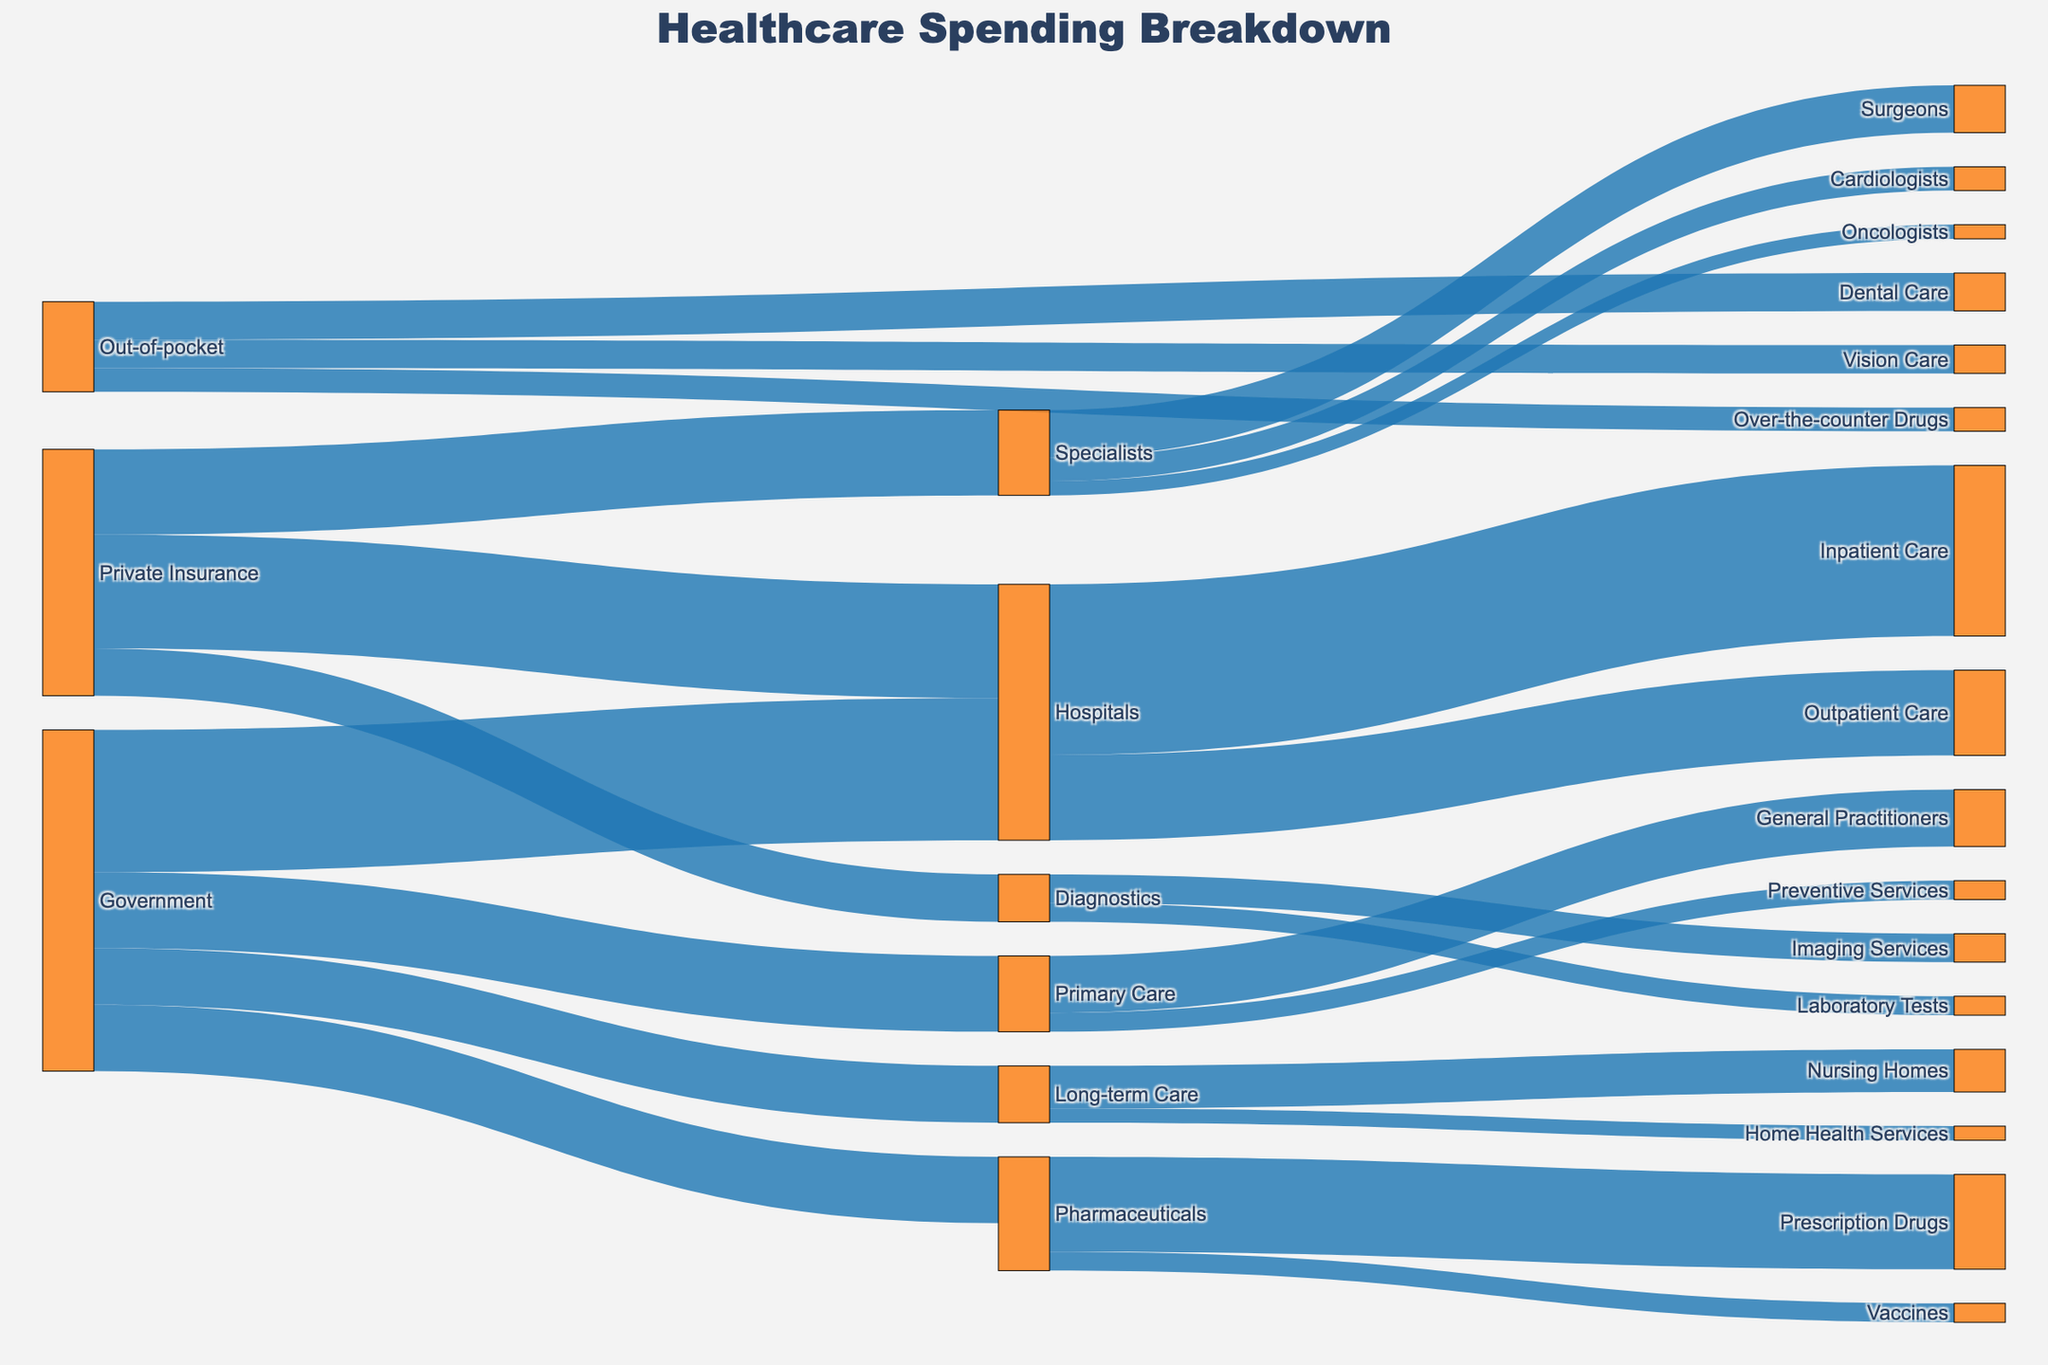What is the total healthcare spending by the Government? Sum the values directed from the Government to each target (Hospitals, Primary Care, Pharmaceuticals, Long-term Care): 150 + 80 + 70 + 60 = 360
Answer: 360 What sector receives the highest funding from Private Insurance? Compare the values directed from Private Insurance to Hospitals, Specialists, and Diagnostics. Hospitals receive 120, Specialists receive 90, and Diagnostics receive 50. The highest is Hospitals with 120
Answer: Hospitals What is the total spending on Hospitals regardless of the funding source? Sum the values directed to Hospitals from Government (150) and Private Insurance (120): 150 + 120 = 270
Answer: 270 How much is spent on General Practitioners from Primary Care? Refer to the target value from Primary Care to General Practitioners, which is 60
Answer: 60 Which funding source contributes the least to healthcare spending? Compare the total contributions by Government (360), Private Insurance (260), and Out-of-pocket (95). The least is Out-of-pocket with 95
Answer: Out-of-pocket What percentage of Government funding goes to Hospitals? Government funding is 360, with 150 going to Hospitals. Calculate the percentage: (150/360) * 100 ≈ 41.67%
Answer: 41.67% What type of service has the highest spending within Specialists? Compare the values directed within Specialists: Surgeons (50), Cardiologists (25), Oncologists (15). The highest is Surgeons with 50
Answer: Surgeons Which sector receives funding from all the funding sources? Identify sectors that get contributions from Government, Private Insurance, and Out-of-pocket. Only Hospitals are funded by both Government and Private Insurance, not by Out-of-pocket
Answer: None What is the combined spending by Out-of-pocket on Dental Care and Vision Care? Sum the values directed from Out-of-pocket to Dental Care (40) and Vision Care (30): 40 + 30 = 70
Answer: 70 Is more money spent on Prescription Drugs or Preventive Services? Compare the values: Pharmaceuticals' Prescription Drugs get 100, Primary Care's Preventive Services get 20. More is spent on Prescription Drugs
Answer: Prescription Drugs 